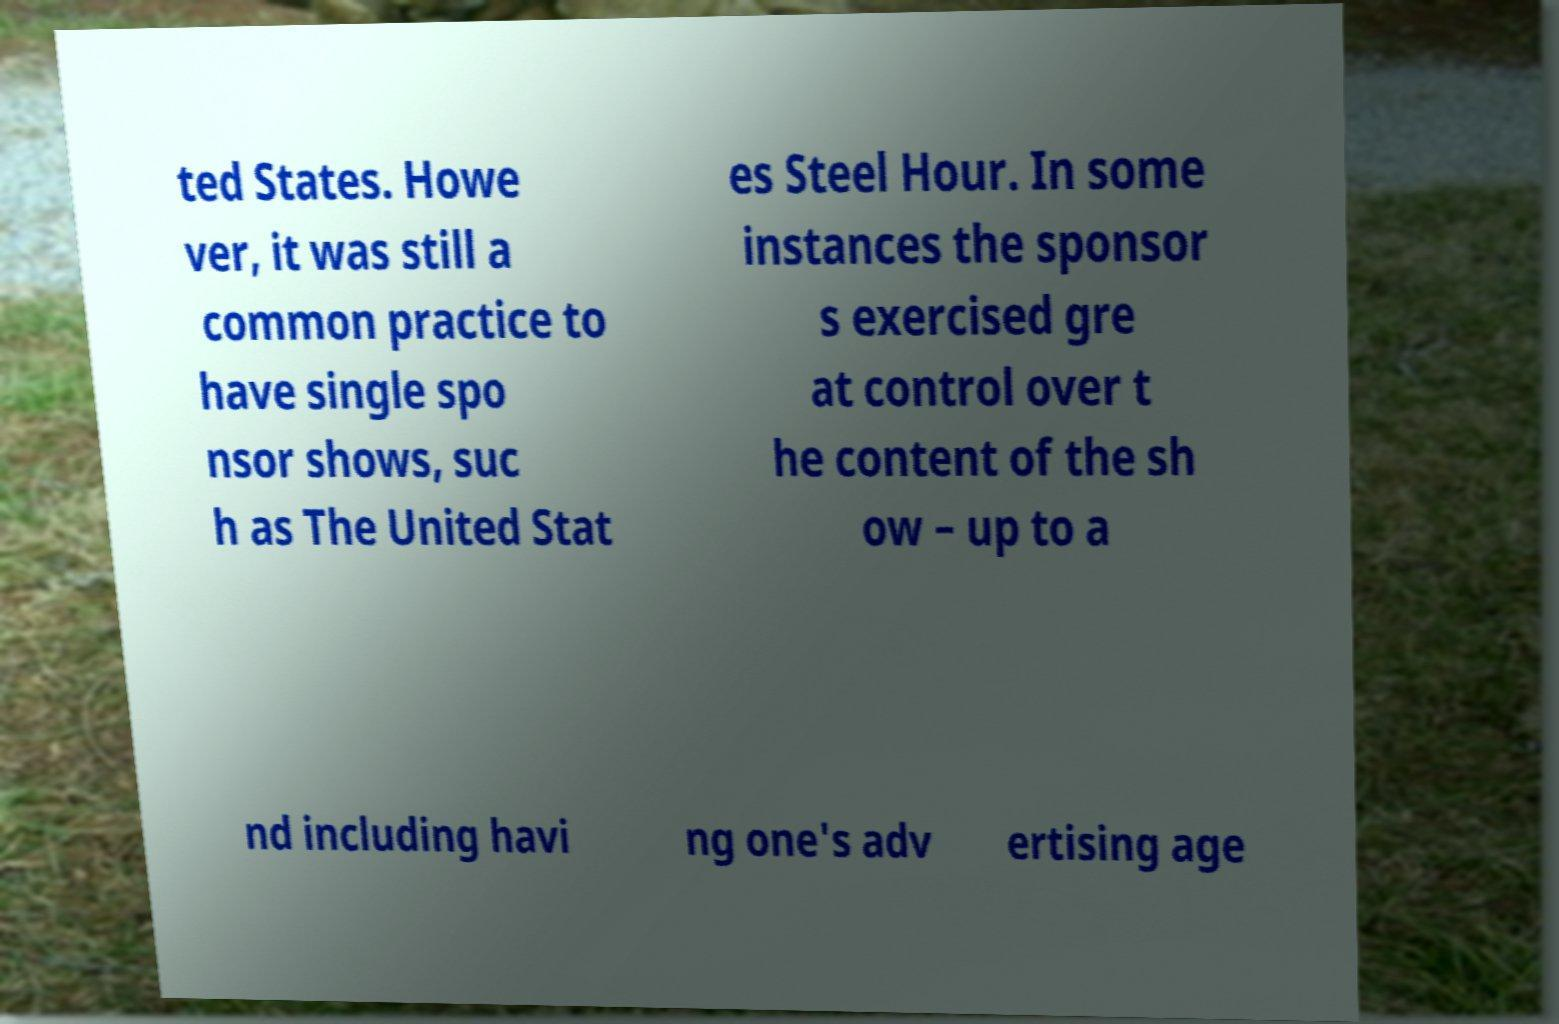There's text embedded in this image that I need extracted. Can you transcribe it verbatim? ted States. Howe ver, it was still a common practice to have single spo nsor shows, suc h as The United Stat es Steel Hour. In some instances the sponsor s exercised gre at control over t he content of the sh ow – up to a nd including havi ng one's adv ertising age 